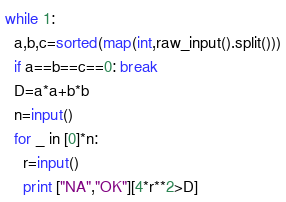Convert code to text. <code><loc_0><loc_0><loc_500><loc_500><_Python_>while 1:
  a,b,c=sorted(map(int,raw_input().split()))
  if a==b==c==0: break
  D=a*a+b*b
  n=input()
  for _ in [0]*n:
    r=input()
    print ["NA","OK"][4*r**2>D]</code> 